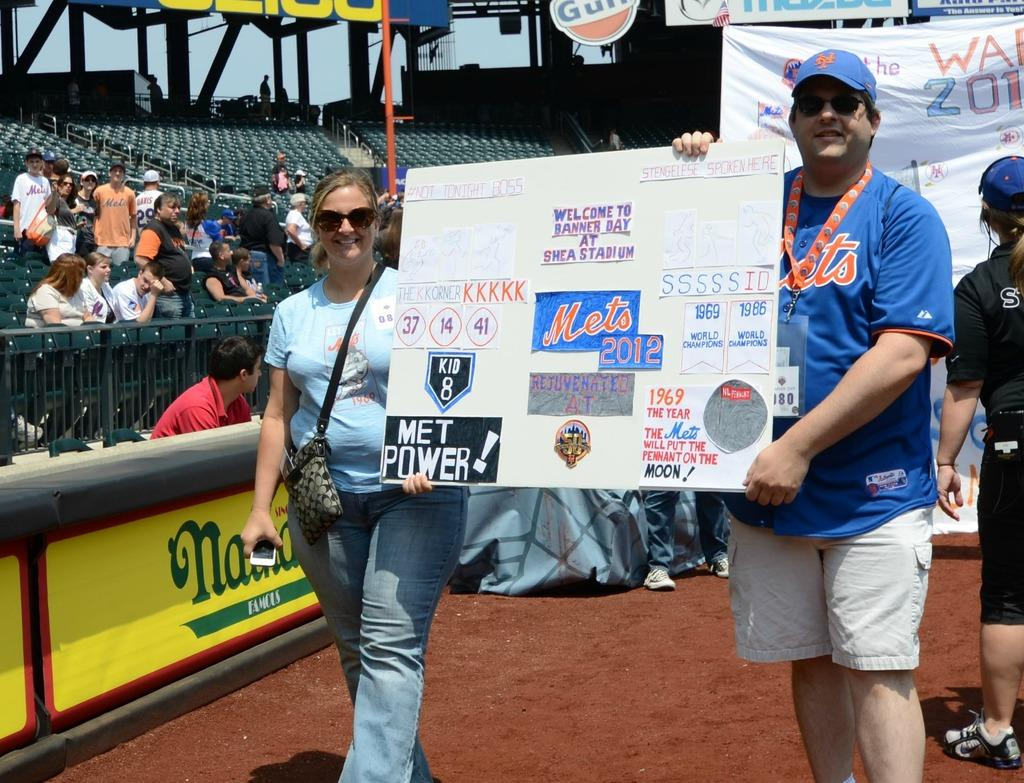<image>
Offer a succinct explanation of the picture presented. Mets fans walk around the field on Banner Day at the old Shea Stadium. 